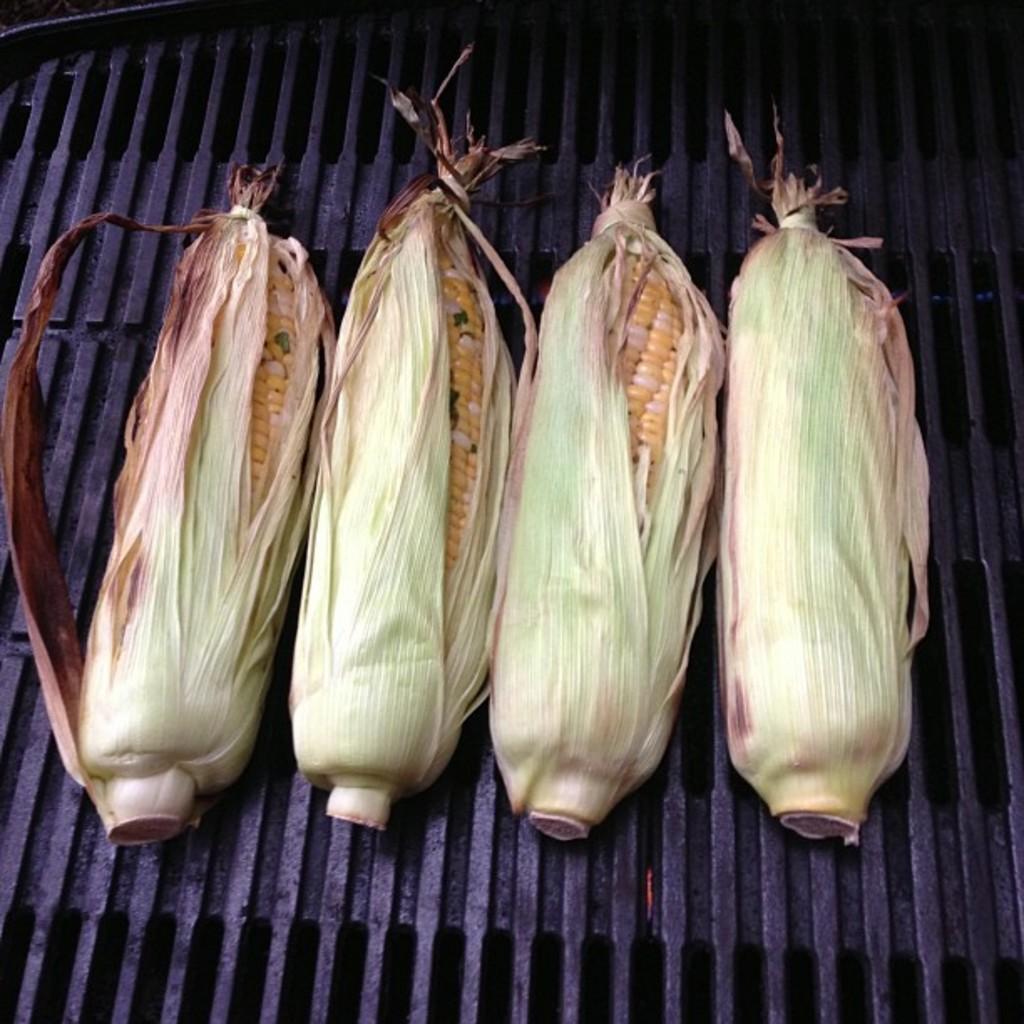Can you describe this image briefly? In this image, we can see four corners with peel is placed on the barbecue. 